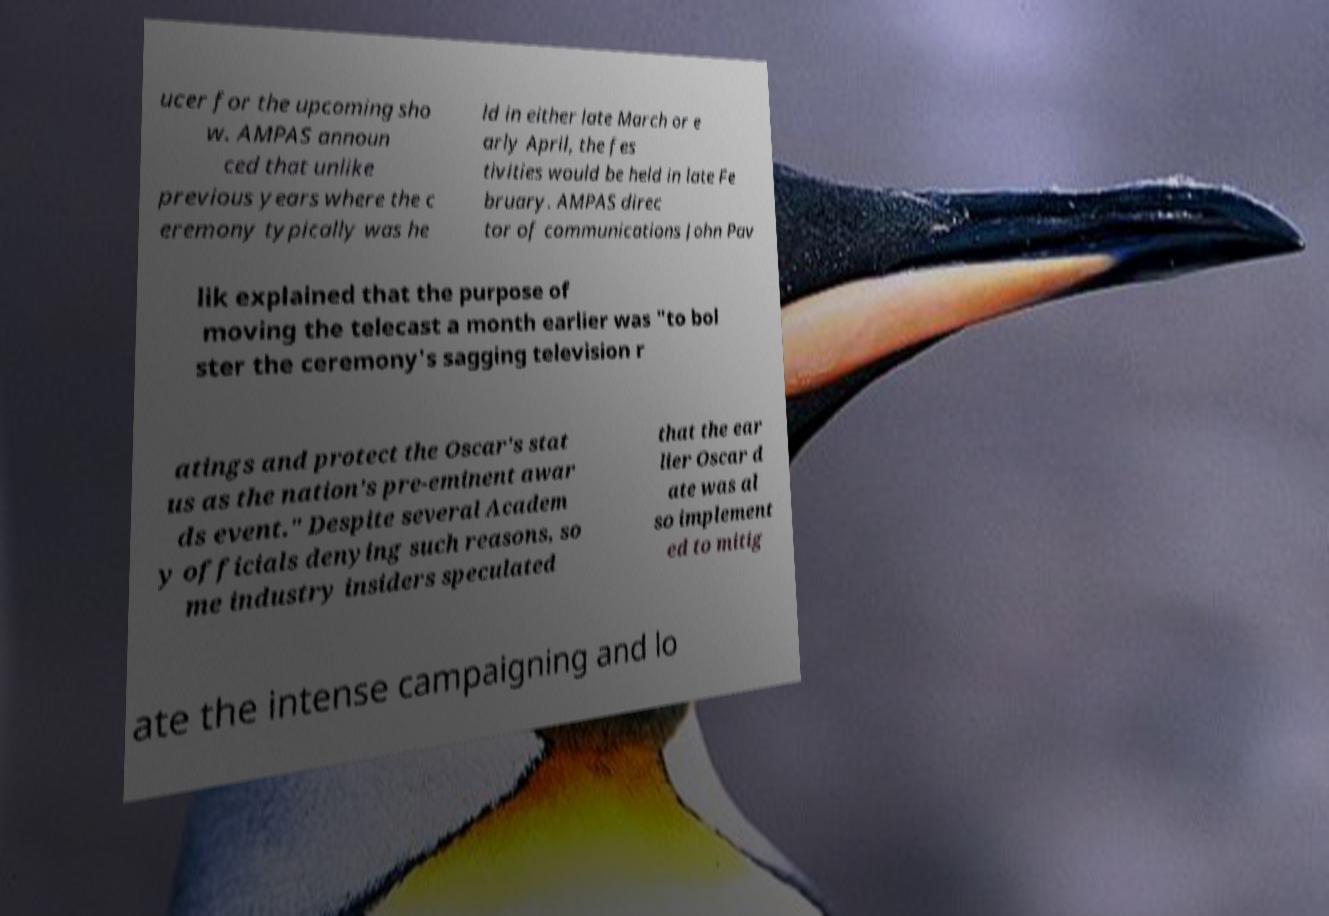There's text embedded in this image that I need extracted. Can you transcribe it verbatim? ucer for the upcoming sho w. AMPAS announ ced that unlike previous years where the c eremony typically was he ld in either late March or e arly April, the fes tivities would be held in late Fe bruary. AMPAS direc tor of communications John Pav lik explained that the purpose of moving the telecast a month earlier was "to bol ster the ceremony's sagging television r atings and protect the Oscar's stat us as the nation's pre-eminent awar ds event." Despite several Academ y officials denying such reasons, so me industry insiders speculated that the ear lier Oscar d ate was al so implement ed to mitig ate the intense campaigning and lo 